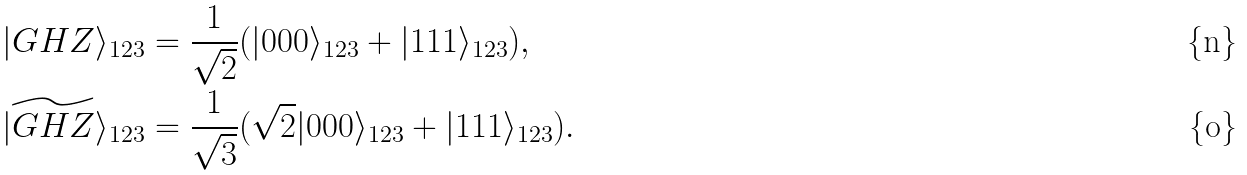Convert formula to latex. <formula><loc_0><loc_0><loc_500><loc_500>& | G H Z \rangle _ { 1 2 3 } = \frac { 1 } { \sqrt { 2 } } ( | 0 0 0 \rangle _ { 1 2 3 } + | 1 1 1 \rangle _ { 1 2 3 } ) , \\ & | \widetilde { G H Z } \rangle _ { 1 2 3 } = \frac { 1 } { \sqrt { 3 } } ( \sqrt { 2 } | 0 0 0 \rangle _ { 1 2 3 } + | 1 1 1 \rangle _ { 1 2 3 } ) .</formula> 